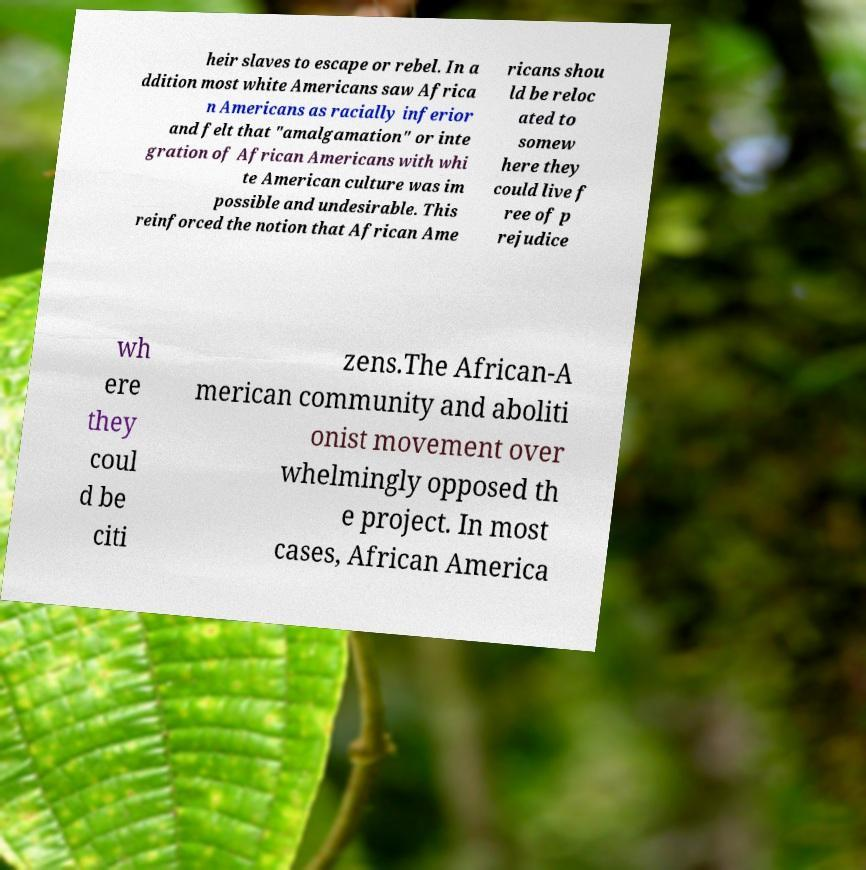What messages or text are displayed in this image? I need them in a readable, typed format. heir slaves to escape or rebel. In a ddition most white Americans saw Africa n Americans as racially inferior and felt that "amalgamation" or inte gration of African Americans with whi te American culture was im possible and undesirable. This reinforced the notion that African Ame ricans shou ld be reloc ated to somew here they could live f ree of p rejudice wh ere they coul d be citi zens.The African-A merican community and aboliti onist movement over whelmingly opposed th e project. In most cases, African America 